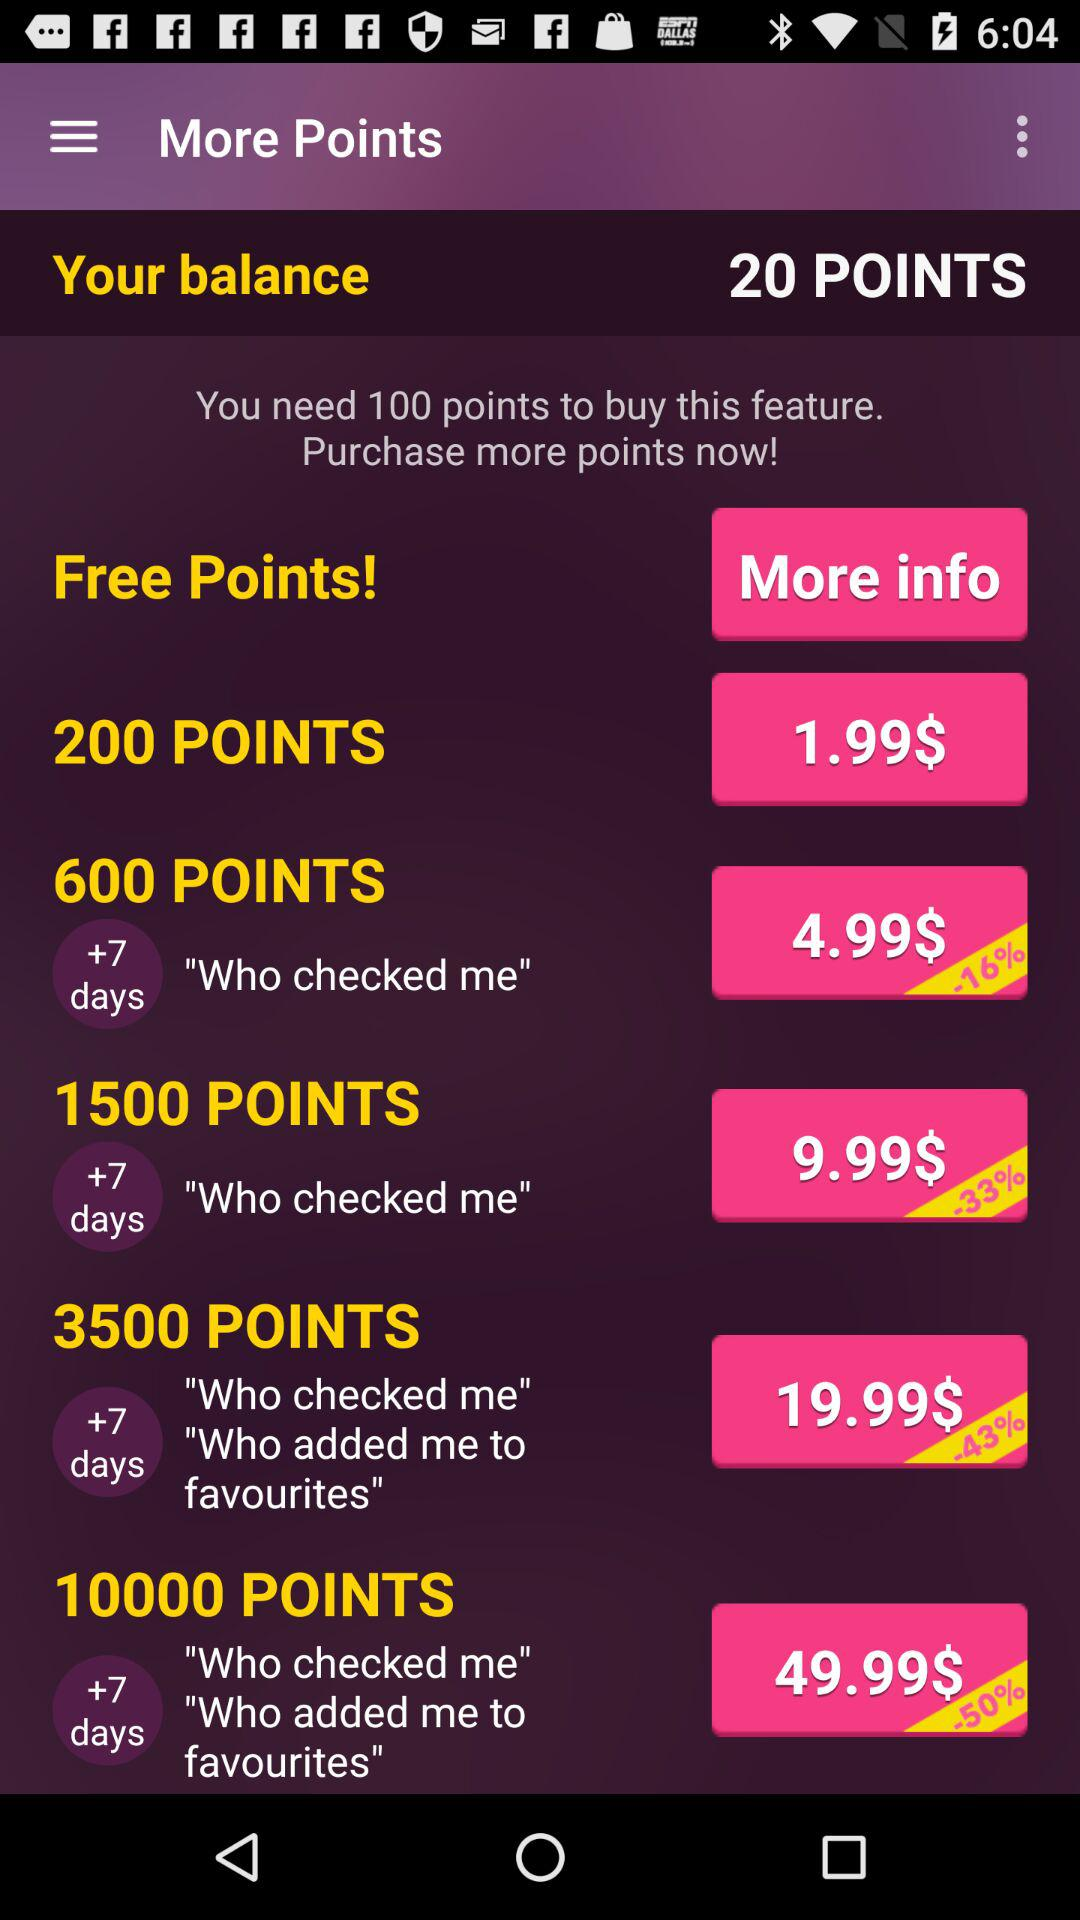What is the value of 1500 points? The value is 9.99$. 